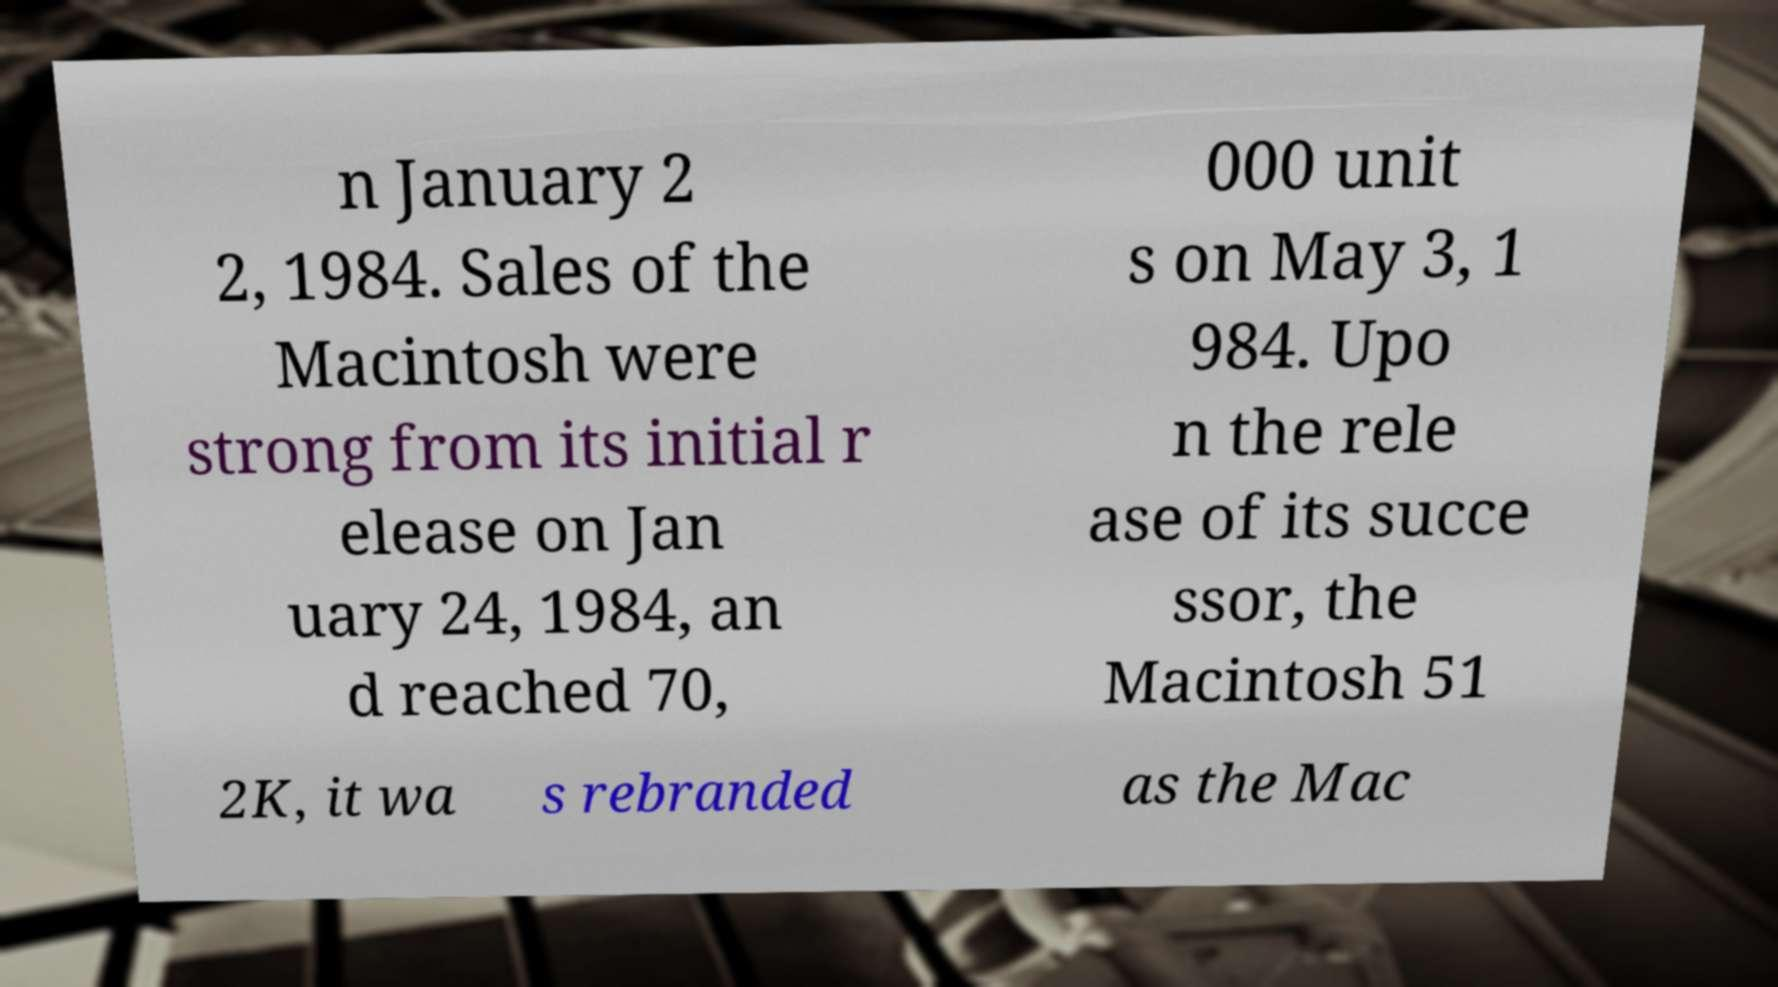Could you assist in decoding the text presented in this image and type it out clearly? n January 2 2, 1984. Sales of the Macintosh were strong from its initial r elease on Jan uary 24, 1984, an d reached 70, 000 unit s on May 3, 1 984. Upo n the rele ase of its succe ssor, the Macintosh 51 2K, it wa s rebranded as the Mac 